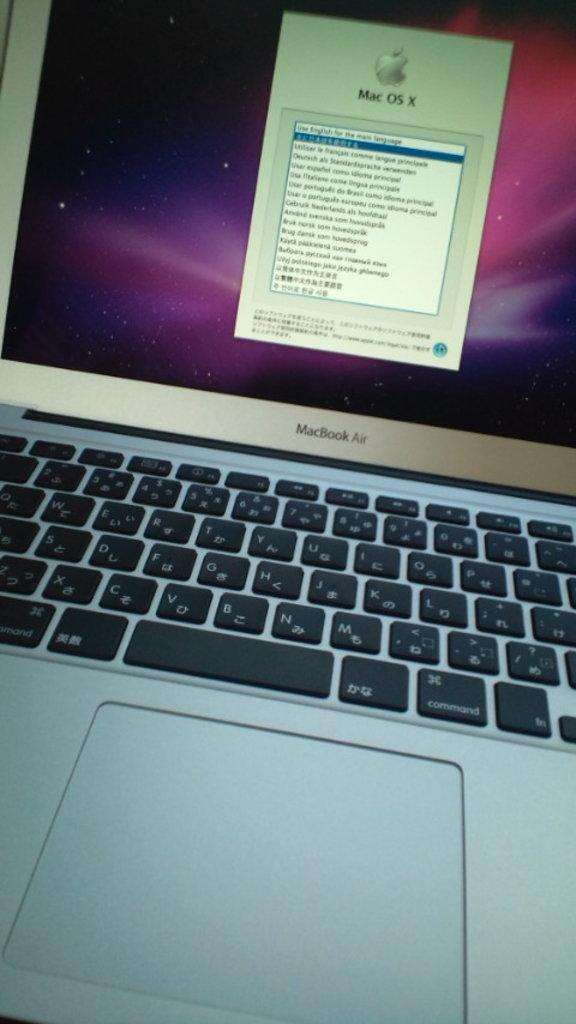Provide a one-sentence caption for the provided image. a macbook air open and on a screen that says mac os x. 